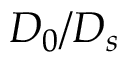<formula> <loc_0><loc_0><loc_500><loc_500>D _ { 0 } / D _ { s }</formula> 